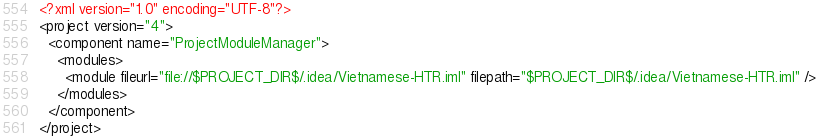Convert code to text. <code><loc_0><loc_0><loc_500><loc_500><_XML_><?xml version="1.0" encoding="UTF-8"?>
<project version="4">
  <component name="ProjectModuleManager">
    <modules>
      <module fileurl="file://$PROJECT_DIR$/.idea/Vietnamese-HTR.iml" filepath="$PROJECT_DIR$/.idea/Vietnamese-HTR.iml" />
    </modules>
  </component>
</project></code> 